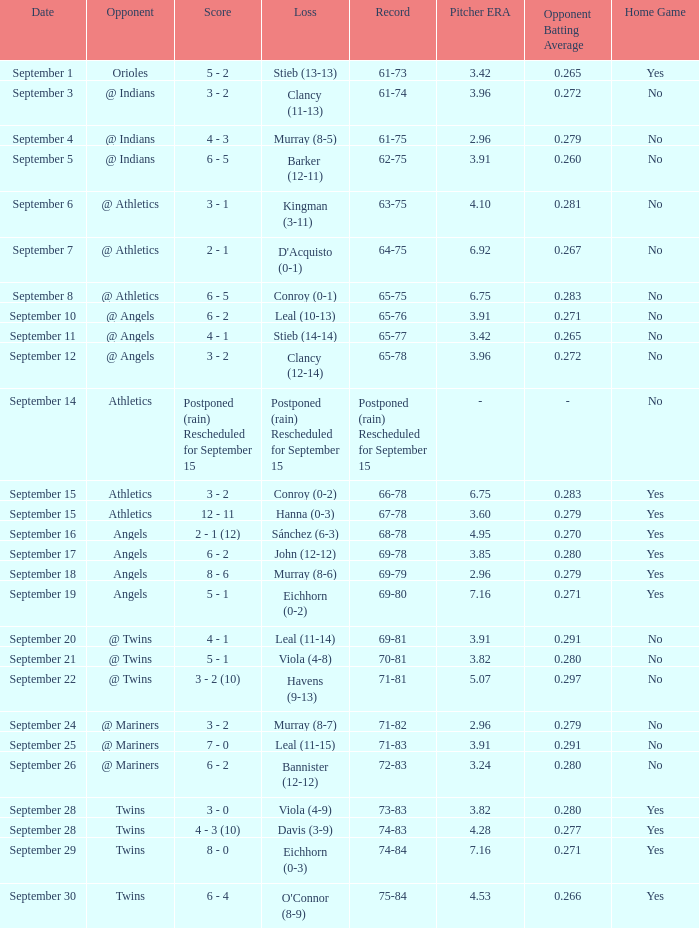Name the score for september 11 4 - 1. 